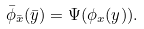<formula> <loc_0><loc_0><loc_500><loc_500>\bar { \phi } _ { \bar { x } } ( \bar { y } ) = \Psi ( \phi _ { x } ( y ) ) .</formula> 